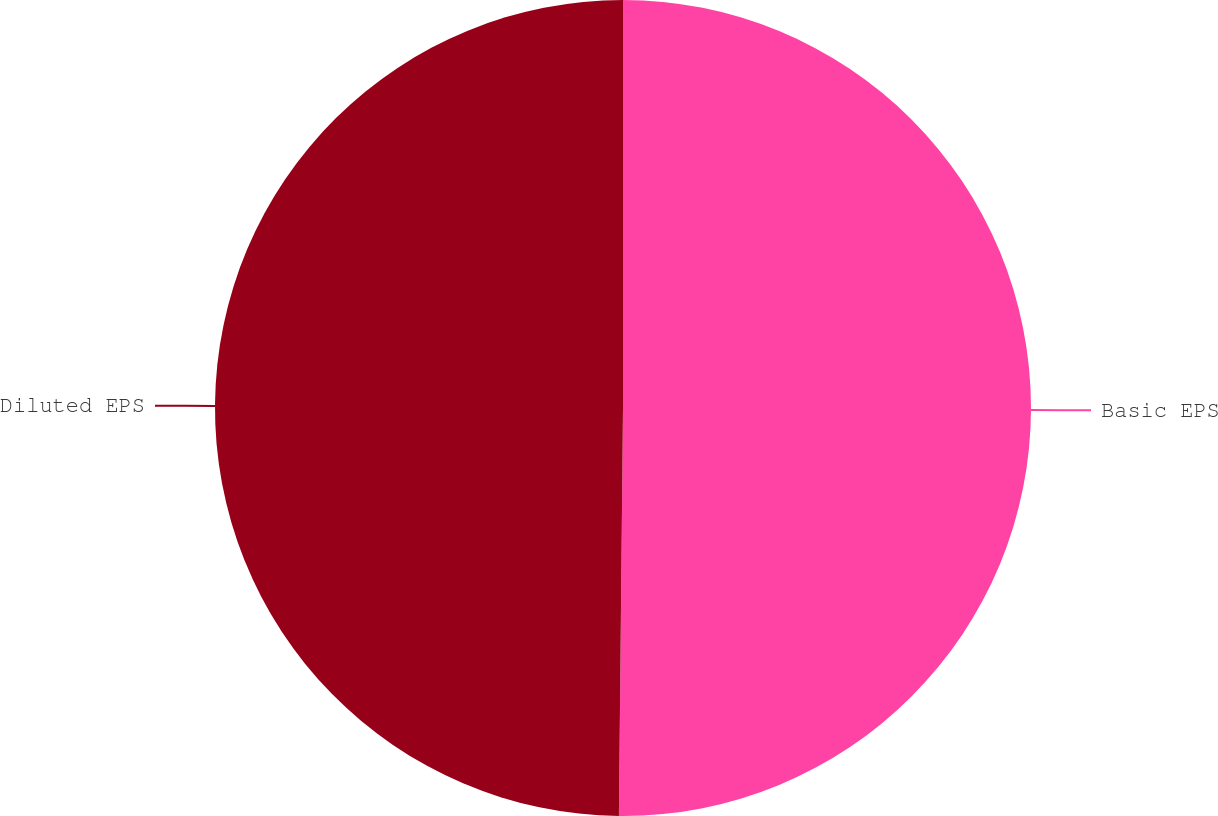Convert chart. <chart><loc_0><loc_0><loc_500><loc_500><pie_chart><fcel>Basic EPS<fcel>Diluted EPS<nl><fcel>50.16%<fcel>49.84%<nl></chart> 